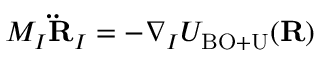Convert formula to latex. <formula><loc_0><loc_0><loc_500><loc_500>M _ { I } { \ddot { R } } _ { I } = - \nabla _ { I } U _ { B O + U } ( { R } )</formula> 